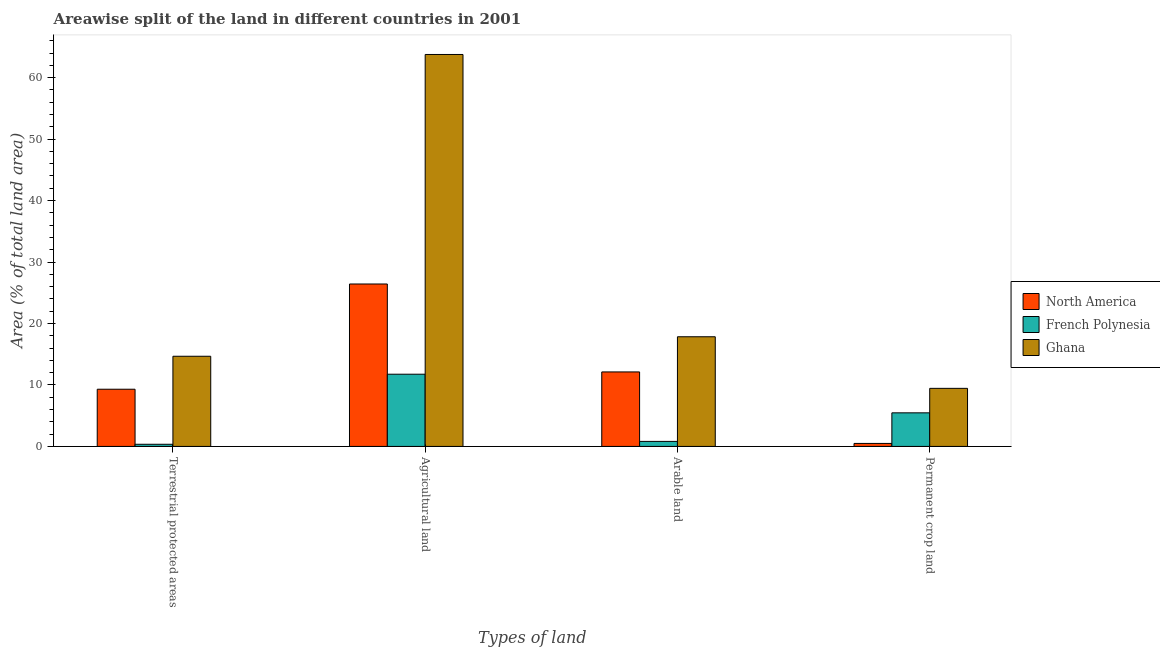How many different coloured bars are there?
Give a very brief answer. 3. How many groups of bars are there?
Give a very brief answer. 4. Are the number of bars per tick equal to the number of legend labels?
Ensure brevity in your answer.  Yes. How many bars are there on the 2nd tick from the left?
Provide a succinct answer. 3. How many bars are there on the 2nd tick from the right?
Your answer should be compact. 3. What is the label of the 2nd group of bars from the left?
Keep it short and to the point. Agricultural land. What is the percentage of area under agricultural land in Ghana?
Offer a terse response. 63.77. Across all countries, what is the maximum percentage of land under terrestrial protection?
Ensure brevity in your answer.  14.67. Across all countries, what is the minimum percentage of land under terrestrial protection?
Your response must be concise. 0.35. In which country was the percentage of area under permanent crop land maximum?
Offer a very short reply. Ghana. In which country was the percentage of land under terrestrial protection minimum?
Provide a succinct answer. French Polynesia. What is the total percentage of area under permanent crop land in the graph?
Your response must be concise. 15.4. What is the difference between the percentage of area under permanent crop land in Ghana and that in North America?
Ensure brevity in your answer.  8.96. What is the difference between the percentage of land under terrestrial protection in Ghana and the percentage of area under arable land in French Polynesia?
Your response must be concise. 13.85. What is the average percentage of area under arable land per country?
Provide a short and direct response. 10.26. What is the difference between the percentage of area under arable land and percentage of land under terrestrial protection in French Polynesia?
Offer a very short reply. 0.47. What is the ratio of the percentage of area under agricultural land in North America to that in Ghana?
Your response must be concise. 0.41. What is the difference between the highest and the second highest percentage of area under agricultural land?
Your response must be concise. 37.34. What is the difference between the highest and the lowest percentage of area under permanent crop land?
Offer a terse response. 8.96. In how many countries, is the percentage of area under permanent crop land greater than the average percentage of area under permanent crop land taken over all countries?
Give a very brief answer. 2. What does the 2nd bar from the left in Terrestrial protected areas represents?
Offer a very short reply. French Polynesia. What does the 2nd bar from the right in Arable land represents?
Give a very brief answer. French Polynesia. Is it the case that in every country, the sum of the percentage of land under terrestrial protection and percentage of area under agricultural land is greater than the percentage of area under arable land?
Offer a terse response. Yes. Are all the bars in the graph horizontal?
Ensure brevity in your answer.  No. How many countries are there in the graph?
Give a very brief answer. 3. What is the difference between two consecutive major ticks on the Y-axis?
Provide a short and direct response. 10. Are the values on the major ticks of Y-axis written in scientific E-notation?
Keep it short and to the point. No. How many legend labels are there?
Ensure brevity in your answer.  3. What is the title of the graph?
Keep it short and to the point. Areawise split of the land in different countries in 2001. What is the label or title of the X-axis?
Your answer should be very brief. Types of land. What is the label or title of the Y-axis?
Keep it short and to the point. Area (% of total land area). What is the Area (% of total land area) of North America in Terrestrial protected areas?
Keep it short and to the point. 9.31. What is the Area (% of total land area) of French Polynesia in Terrestrial protected areas?
Ensure brevity in your answer.  0.35. What is the Area (% of total land area) in Ghana in Terrestrial protected areas?
Provide a short and direct response. 14.67. What is the Area (% of total land area) in North America in Agricultural land?
Your answer should be very brief. 26.43. What is the Area (% of total land area) in French Polynesia in Agricultural land?
Keep it short and to the point. 11.75. What is the Area (% of total land area) in Ghana in Agricultural land?
Make the answer very short. 63.77. What is the Area (% of total land area) of North America in Arable land?
Your answer should be compact. 12.12. What is the Area (% of total land area) in French Polynesia in Arable land?
Provide a short and direct response. 0.82. What is the Area (% of total land area) of Ghana in Arable land?
Provide a short and direct response. 17.84. What is the Area (% of total land area) in North America in Permanent crop land?
Your answer should be very brief. 0.49. What is the Area (% of total land area) of French Polynesia in Permanent crop land?
Your answer should be compact. 5.46. What is the Area (% of total land area) of Ghana in Permanent crop land?
Offer a terse response. 9.45. Across all Types of land, what is the maximum Area (% of total land area) of North America?
Give a very brief answer. 26.43. Across all Types of land, what is the maximum Area (% of total land area) of French Polynesia?
Make the answer very short. 11.75. Across all Types of land, what is the maximum Area (% of total land area) of Ghana?
Offer a very short reply. 63.77. Across all Types of land, what is the minimum Area (% of total land area) in North America?
Your response must be concise. 0.49. Across all Types of land, what is the minimum Area (% of total land area) in French Polynesia?
Offer a very short reply. 0.35. Across all Types of land, what is the minimum Area (% of total land area) in Ghana?
Ensure brevity in your answer.  9.45. What is the total Area (% of total land area) of North America in the graph?
Make the answer very short. 48.34. What is the total Area (% of total land area) in French Polynesia in the graph?
Your answer should be very brief. 18.38. What is the total Area (% of total land area) in Ghana in the graph?
Offer a very short reply. 105.73. What is the difference between the Area (% of total land area) of North America in Terrestrial protected areas and that in Agricultural land?
Your answer should be compact. -17.12. What is the difference between the Area (% of total land area) in French Polynesia in Terrestrial protected areas and that in Agricultural land?
Give a very brief answer. -11.4. What is the difference between the Area (% of total land area) of Ghana in Terrestrial protected areas and that in Agricultural land?
Offer a very short reply. -49.1. What is the difference between the Area (% of total land area) of North America in Terrestrial protected areas and that in Arable land?
Offer a very short reply. -2.81. What is the difference between the Area (% of total land area) of French Polynesia in Terrestrial protected areas and that in Arable land?
Give a very brief answer. -0.47. What is the difference between the Area (% of total land area) in Ghana in Terrestrial protected areas and that in Arable land?
Provide a short and direct response. -3.17. What is the difference between the Area (% of total land area) in North America in Terrestrial protected areas and that in Permanent crop land?
Your response must be concise. 8.82. What is the difference between the Area (% of total land area) in French Polynesia in Terrestrial protected areas and that in Permanent crop land?
Make the answer very short. -5.11. What is the difference between the Area (% of total land area) in Ghana in Terrestrial protected areas and that in Permanent crop land?
Make the answer very short. 5.22. What is the difference between the Area (% of total land area) in North America in Agricultural land and that in Arable land?
Ensure brevity in your answer.  14.31. What is the difference between the Area (% of total land area) of French Polynesia in Agricultural land and that in Arable land?
Ensure brevity in your answer.  10.93. What is the difference between the Area (% of total land area) of Ghana in Agricultural land and that in Arable land?
Your response must be concise. 45.93. What is the difference between the Area (% of total land area) in North America in Agricultural land and that in Permanent crop land?
Provide a succinct answer. 25.94. What is the difference between the Area (% of total land area) in French Polynesia in Agricultural land and that in Permanent crop land?
Keep it short and to the point. 6.28. What is the difference between the Area (% of total land area) in Ghana in Agricultural land and that in Permanent crop land?
Your answer should be compact. 54.32. What is the difference between the Area (% of total land area) in North America in Arable land and that in Permanent crop land?
Make the answer very short. 11.63. What is the difference between the Area (% of total land area) in French Polynesia in Arable land and that in Permanent crop land?
Your response must be concise. -4.64. What is the difference between the Area (% of total land area) of Ghana in Arable land and that in Permanent crop land?
Your response must be concise. 8.39. What is the difference between the Area (% of total land area) in North America in Terrestrial protected areas and the Area (% of total land area) in French Polynesia in Agricultural land?
Offer a very short reply. -2.44. What is the difference between the Area (% of total land area) in North America in Terrestrial protected areas and the Area (% of total land area) in Ghana in Agricultural land?
Offer a very short reply. -54.46. What is the difference between the Area (% of total land area) in French Polynesia in Terrestrial protected areas and the Area (% of total land area) in Ghana in Agricultural land?
Provide a succinct answer. -63.42. What is the difference between the Area (% of total land area) in North America in Terrestrial protected areas and the Area (% of total land area) in French Polynesia in Arable land?
Keep it short and to the point. 8.49. What is the difference between the Area (% of total land area) of North America in Terrestrial protected areas and the Area (% of total land area) of Ghana in Arable land?
Your answer should be compact. -8.54. What is the difference between the Area (% of total land area) in French Polynesia in Terrestrial protected areas and the Area (% of total land area) in Ghana in Arable land?
Ensure brevity in your answer.  -17.49. What is the difference between the Area (% of total land area) of North America in Terrestrial protected areas and the Area (% of total land area) of French Polynesia in Permanent crop land?
Keep it short and to the point. 3.84. What is the difference between the Area (% of total land area) of North America in Terrestrial protected areas and the Area (% of total land area) of Ghana in Permanent crop land?
Your answer should be very brief. -0.14. What is the difference between the Area (% of total land area) of French Polynesia in Terrestrial protected areas and the Area (% of total land area) of Ghana in Permanent crop land?
Your answer should be very brief. -9.1. What is the difference between the Area (% of total land area) in North America in Agricultural land and the Area (% of total land area) in French Polynesia in Arable land?
Offer a very short reply. 25.61. What is the difference between the Area (% of total land area) in North America in Agricultural land and the Area (% of total land area) in Ghana in Arable land?
Make the answer very short. 8.58. What is the difference between the Area (% of total land area) of French Polynesia in Agricultural land and the Area (% of total land area) of Ghana in Arable land?
Your answer should be very brief. -6.09. What is the difference between the Area (% of total land area) in North America in Agricultural land and the Area (% of total land area) in French Polynesia in Permanent crop land?
Give a very brief answer. 20.96. What is the difference between the Area (% of total land area) of North America in Agricultural land and the Area (% of total land area) of Ghana in Permanent crop land?
Ensure brevity in your answer.  16.98. What is the difference between the Area (% of total land area) of French Polynesia in Agricultural land and the Area (% of total land area) of Ghana in Permanent crop land?
Offer a terse response. 2.3. What is the difference between the Area (% of total land area) in North America in Arable land and the Area (% of total land area) in French Polynesia in Permanent crop land?
Provide a short and direct response. 6.66. What is the difference between the Area (% of total land area) in North America in Arable land and the Area (% of total land area) in Ghana in Permanent crop land?
Offer a very short reply. 2.67. What is the difference between the Area (% of total land area) of French Polynesia in Arable land and the Area (% of total land area) of Ghana in Permanent crop land?
Your response must be concise. -8.63. What is the average Area (% of total land area) in North America per Types of land?
Make the answer very short. 12.09. What is the average Area (% of total land area) of French Polynesia per Types of land?
Your response must be concise. 4.6. What is the average Area (% of total land area) in Ghana per Types of land?
Ensure brevity in your answer.  26.43. What is the difference between the Area (% of total land area) of North America and Area (% of total land area) of French Polynesia in Terrestrial protected areas?
Your response must be concise. 8.96. What is the difference between the Area (% of total land area) of North America and Area (% of total land area) of Ghana in Terrestrial protected areas?
Give a very brief answer. -5.36. What is the difference between the Area (% of total land area) of French Polynesia and Area (% of total land area) of Ghana in Terrestrial protected areas?
Make the answer very short. -14.32. What is the difference between the Area (% of total land area) of North America and Area (% of total land area) of French Polynesia in Agricultural land?
Make the answer very short. 14.68. What is the difference between the Area (% of total land area) in North America and Area (% of total land area) in Ghana in Agricultural land?
Your answer should be very brief. -37.34. What is the difference between the Area (% of total land area) in French Polynesia and Area (% of total land area) in Ghana in Agricultural land?
Give a very brief answer. -52.02. What is the difference between the Area (% of total land area) in North America and Area (% of total land area) in French Polynesia in Arable land?
Offer a very short reply. 11.3. What is the difference between the Area (% of total land area) in North America and Area (% of total land area) in Ghana in Arable land?
Your answer should be very brief. -5.72. What is the difference between the Area (% of total land area) of French Polynesia and Area (% of total land area) of Ghana in Arable land?
Your response must be concise. -17.02. What is the difference between the Area (% of total land area) in North America and Area (% of total land area) in French Polynesia in Permanent crop land?
Offer a very short reply. -4.98. What is the difference between the Area (% of total land area) of North America and Area (% of total land area) of Ghana in Permanent crop land?
Provide a short and direct response. -8.96. What is the difference between the Area (% of total land area) in French Polynesia and Area (% of total land area) in Ghana in Permanent crop land?
Offer a very short reply. -3.98. What is the ratio of the Area (% of total land area) of North America in Terrestrial protected areas to that in Agricultural land?
Offer a very short reply. 0.35. What is the ratio of the Area (% of total land area) of French Polynesia in Terrestrial protected areas to that in Agricultural land?
Offer a very short reply. 0.03. What is the ratio of the Area (% of total land area) in Ghana in Terrestrial protected areas to that in Agricultural land?
Keep it short and to the point. 0.23. What is the ratio of the Area (% of total land area) of North America in Terrestrial protected areas to that in Arable land?
Offer a terse response. 0.77. What is the ratio of the Area (% of total land area) in French Polynesia in Terrestrial protected areas to that in Arable land?
Your response must be concise. 0.43. What is the ratio of the Area (% of total land area) of Ghana in Terrestrial protected areas to that in Arable land?
Offer a terse response. 0.82. What is the ratio of the Area (% of total land area) of North America in Terrestrial protected areas to that in Permanent crop land?
Offer a terse response. 19.02. What is the ratio of the Area (% of total land area) in French Polynesia in Terrestrial protected areas to that in Permanent crop land?
Your response must be concise. 0.06. What is the ratio of the Area (% of total land area) in Ghana in Terrestrial protected areas to that in Permanent crop land?
Provide a short and direct response. 1.55. What is the ratio of the Area (% of total land area) in North America in Agricultural land to that in Arable land?
Keep it short and to the point. 2.18. What is the ratio of the Area (% of total land area) of French Polynesia in Agricultural land to that in Arable land?
Give a very brief answer. 14.33. What is the ratio of the Area (% of total land area) of Ghana in Agricultural land to that in Arable land?
Ensure brevity in your answer.  3.57. What is the ratio of the Area (% of total land area) in North America in Agricultural land to that in Permanent crop land?
Ensure brevity in your answer.  54.02. What is the ratio of the Area (% of total land area) in French Polynesia in Agricultural land to that in Permanent crop land?
Keep it short and to the point. 2.15. What is the ratio of the Area (% of total land area) in Ghana in Agricultural land to that in Permanent crop land?
Give a very brief answer. 6.75. What is the ratio of the Area (% of total land area) in North America in Arable land to that in Permanent crop land?
Ensure brevity in your answer.  24.78. What is the ratio of the Area (% of total land area) of French Polynesia in Arable land to that in Permanent crop land?
Give a very brief answer. 0.15. What is the ratio of the Area (% of total land area) in Ghana in Arable land to that in Permanent crop land?
Give a very brief answer. 1.89. What is the difference between the highest and the second highest Area (% of total land area) in North America?
Keep it short and to the point. 14.31. What is the difference between the highest and the second highest Area (% of total land area) in French Polynesia?
Your response must be concise. 6.28. What is the difference between the highest and the second highest Area (% of total land area) of Ghana?
Your response must be concise. 45.93. What is the difference between the highest and the lowest Area (% of total land area) in North America?
Your answer should be compact. 25.94. What is the difference between the highest and the lowest Area (% of total land area) in French Polynesia?
Ensure brevity in your answer.  11.4. What is the difference between the highest and the lowest Area (% of total land area) in Ghana?
Your response must be concise. 54.32. 